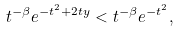Convert formula to latex. <formula><loc_0><loc_0><loc_500><loc_500>t ^ { - \beta } e ^ { - t ^ { 2 } + 2 t y } < t ^ { - \beta } e ^ { - t ^ { 2 } } ,</formula> 